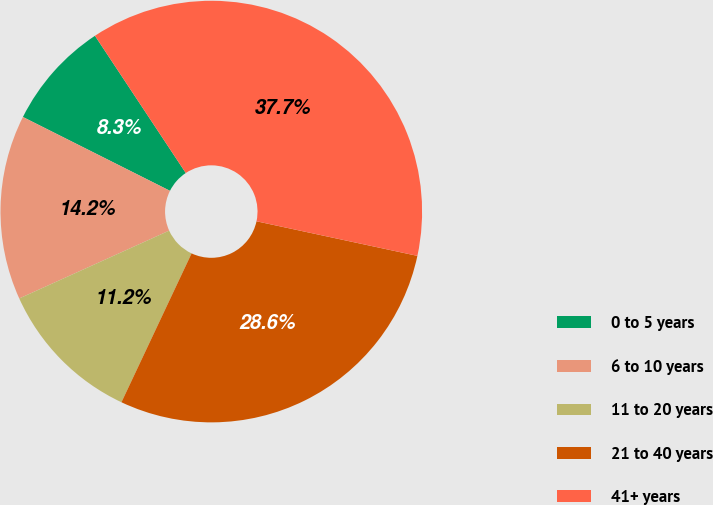<chart> <loc_0><loc_0><loc_500><loc_500><pie_chart><fcel>0 to 5 years<fcel>6 to 10 years<fcel>11 to 20 years<fcel>21 to 40 years<fcel>41+ years<nl><fcel>8.29%<fcel>14.17%<fcel>11.23%<fcel>28.64%<fcel>37.68%<nl></chart> 